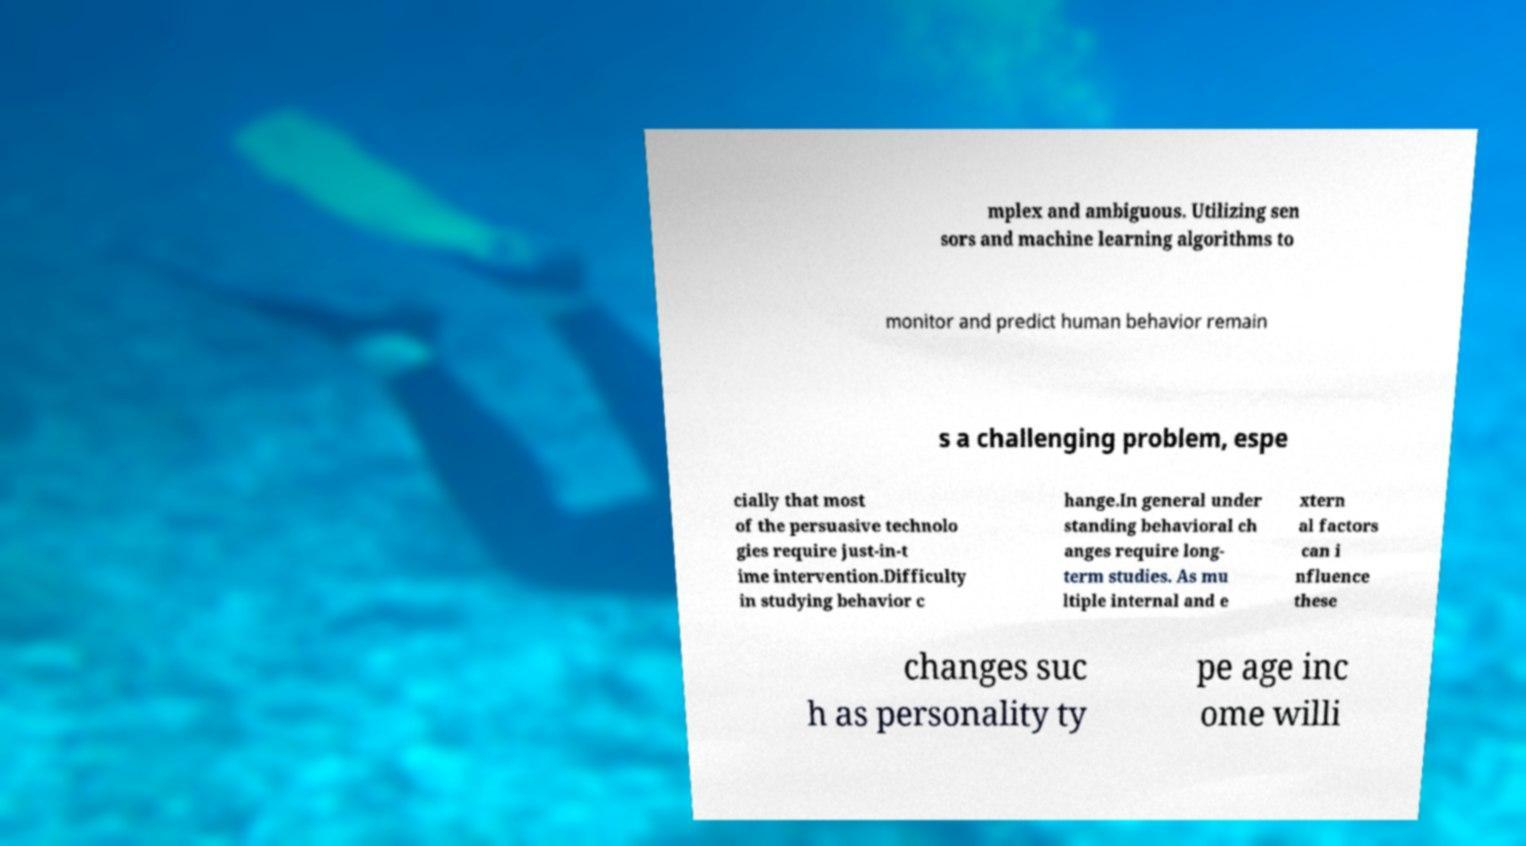I need the written content from this picture converted into text. Can you do that? mplex and ambiguous. Utilizing sen sors and machine learning algorithms to monitor and predict human behavior remain s a challenging problem, espe cially that most of the persuasive technolo gies require just-in-t ime intervention.Difficulty in studying behavior c hange.In general under standing behavioral ch anges require long- term studies. As mu ltiple internal and e xtern al factors can i nfluence these changes suc h as personality ty pe age inc ome willi 